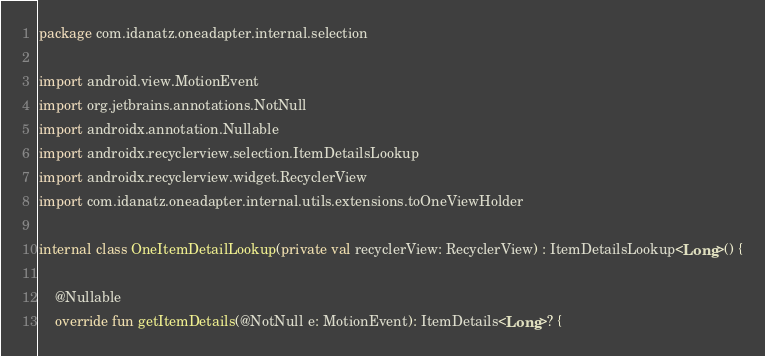<code> <loc_0><loc_0><loc_500><loc_500><_Kotlin_>package com.idanatz.oneadapter.internal.selection

import android.view.MotionEvent
import org.jetbrains.annotations.NotNull
import androidx.annotation.Nullable
import androidx.recyclerview.selection.ItemDetailsLookup
import androidx.recyclerview.widget.RecyclerView
import com.idanatz.oneadapter.internal.utils.extensions.toOneViewHolder

internal class OneItemDetailLookup(private val recyclerView: RecyclerView) : ItemDetailsLookup<Long>() {

    @Nullable
    override fun getItemDetails(@NotNull e: MotionEvent): ItemDetails<Long>? {</code> 